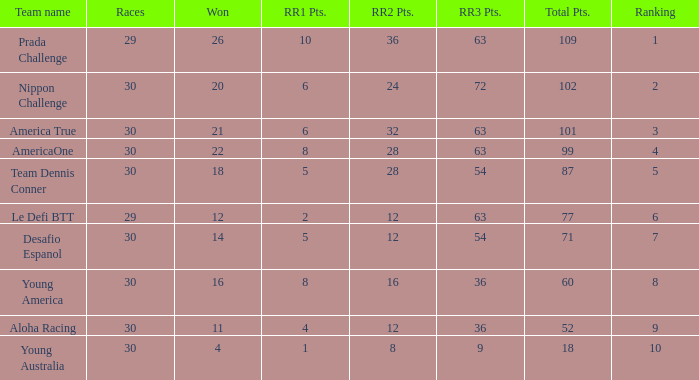Name the races for the prada challenge 29.0. 